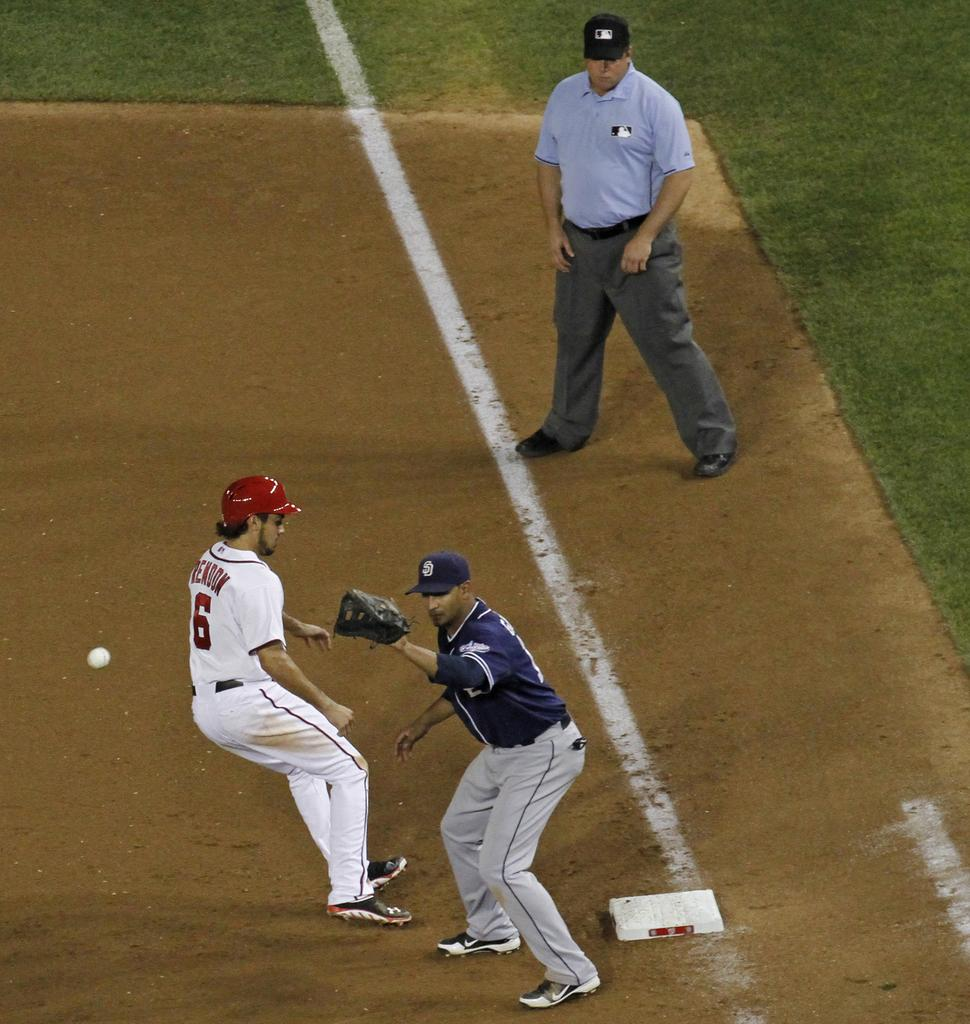<image>
Share a concise interpretation of the image provided. baseball players on a field with one in a 6 jersey 